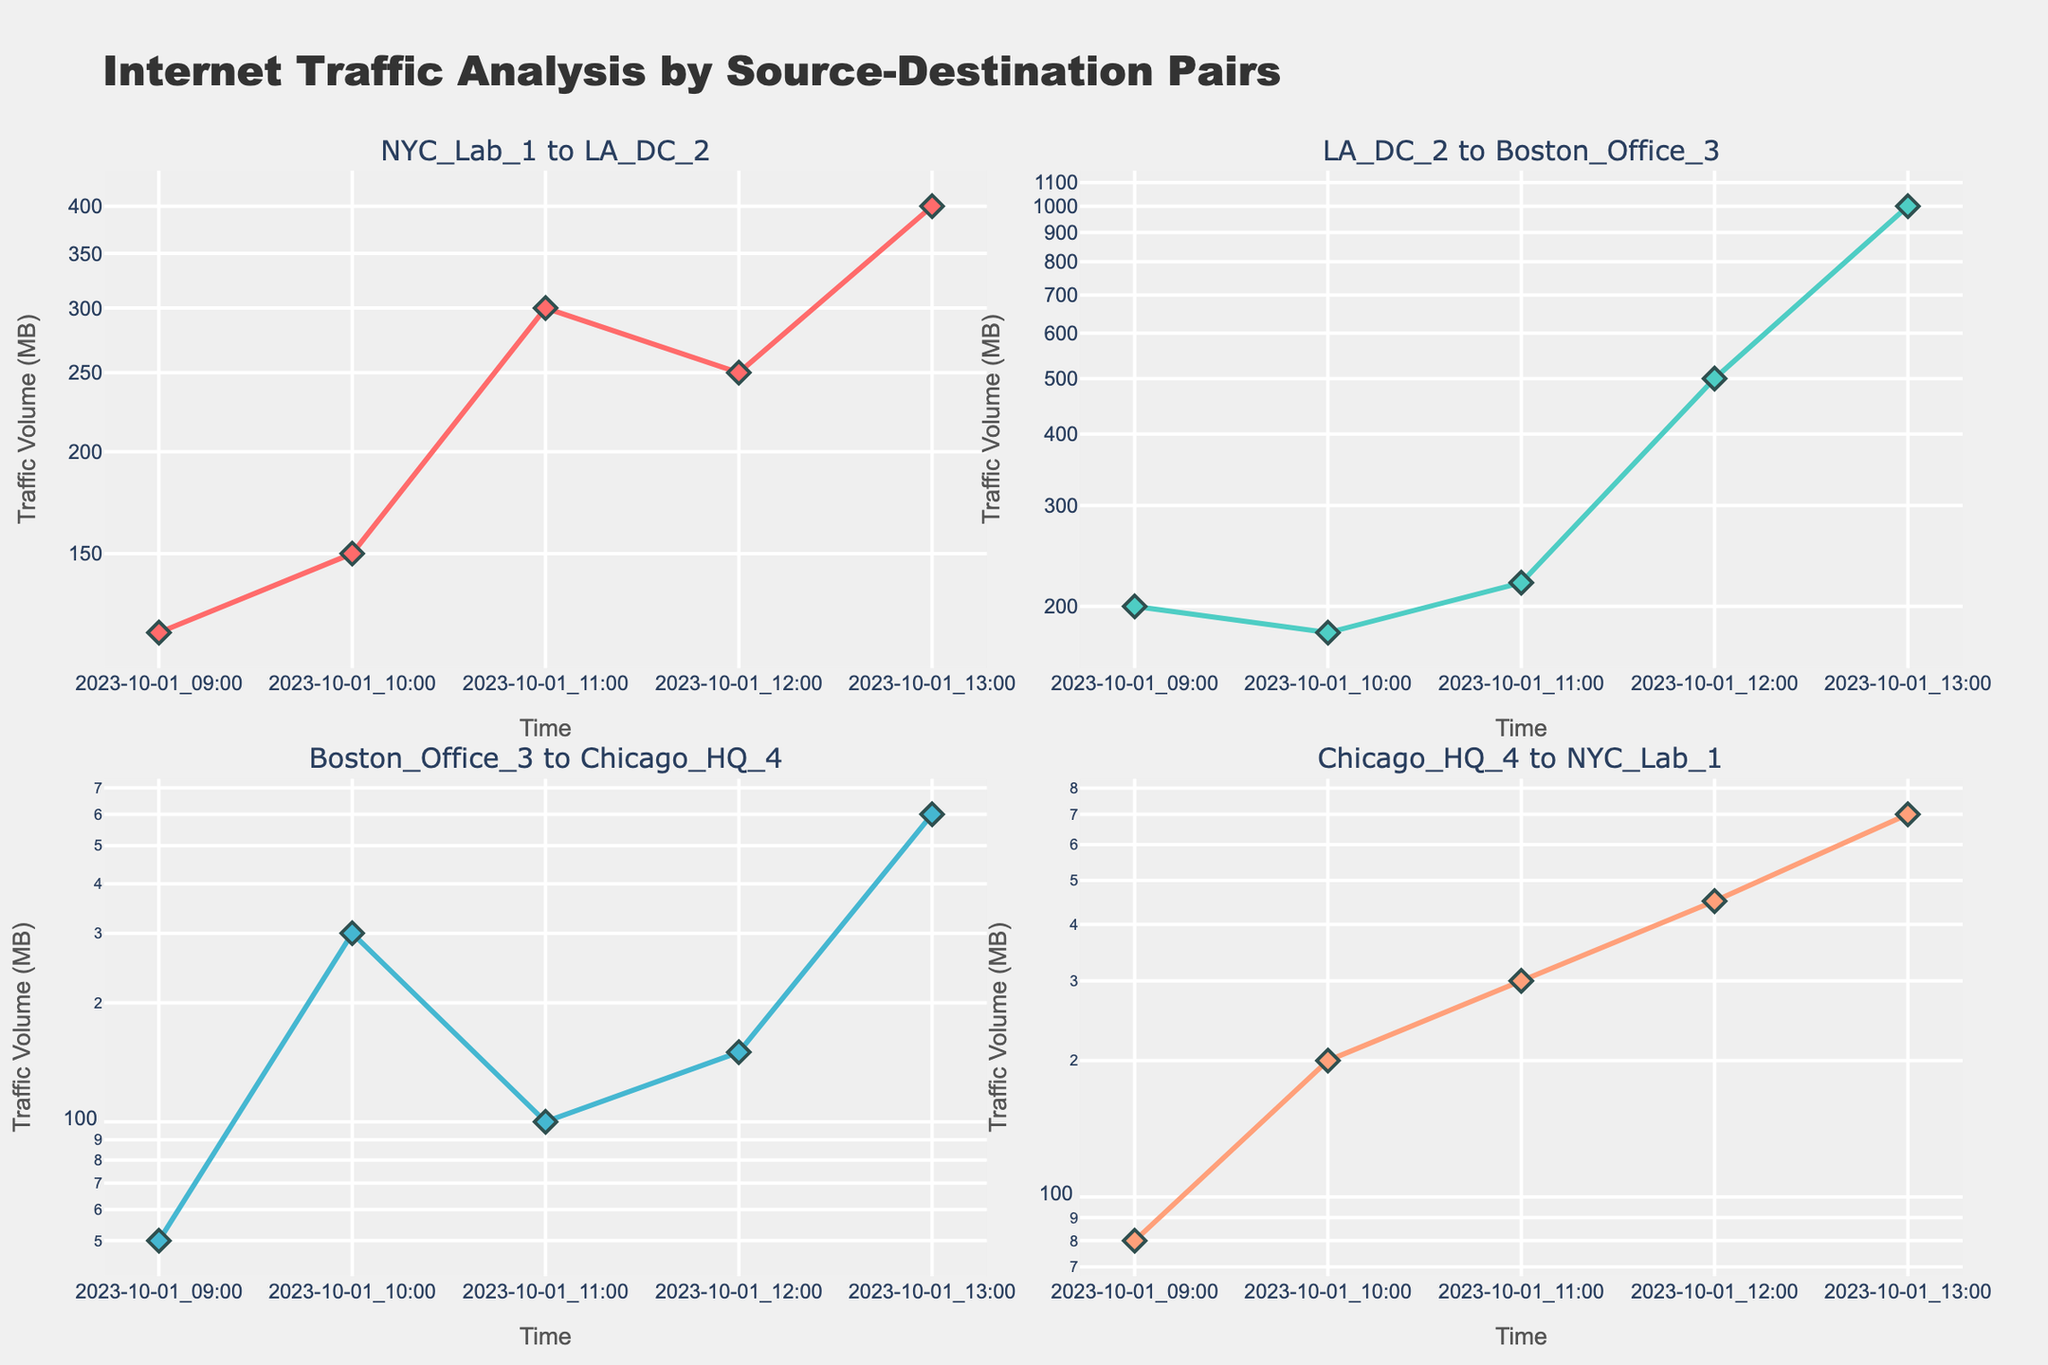What is the title of the figure? The title is displayed at the top of the figure in a larger font size, often descriptive of the overall content or analysis shown in the subplots. The title here is "Internet Traffic Analysis by Source-Destination Pairs".
Answer: Internet Traffic Analysis by Source-Destination Pairs What is the y-axis title in each subplot? Each subplot has a y-axis title that indicates the unit of measurement, which is "Traffic Volume (MB)" as shown next to each y-axis.
Answer: Traffic Volume (MB) How many data points are displayed for the NYC_Lab_1 to LA_DC_2 connection? Counting the markers (diamonds) in the subplot corresponding to NYC_Lab_1 to LA_DC_2 reveals how many data points are presented. This subplot displays 5 data points.
Answer: 5 Which connection shows the highest traffic volume at 13:00? By comparing the y-values at the 13:00 timestamp across all subplots, the highest traffic volume is shown in the LA_DC_2 to Boston_Office_3 connection, which reaches 1000 MB.
Answer: LA_DC_2 to Boston_Office_3 What is the trend in traffic volume for the Boston_Office_3 to Chicago_HQ_4 connection? Observing the line in the subplot for Boston_Office_3 to Chicago_HQ_4, the trend starts with a low volume, spikes at 10:00, decreases again, and then sees another jump at 13:00. This indicates an overall fluctuating pattern with two significant peaks.
Answer: Fluctuating with peaks at 10:00 and 13:00 Compare the traffic volume at 12:00 between the LA_DC_2 to Boston_Office_3 and Chicago_HQ_4 to NYC_Lab_1 connections. Which is higher? Checking the y-values at the 12:00 mark for both connections, LA_DC_2 to Boston_Office_3 has 500 MB while Chicago_HQ_4 to NYC_Lab_1 has 450 MB. Hence, LA_DC_2 to Boston_Office_3 is higher.
Answer: LA_DC_2 to Boston_Office_3 What is the rate of change in traffic volume for the NYC_Lab_1 to LA_DC_2 connection between 11:00 and 12:00? Calculate the difference in traffic volume between 11:00 (300 MB) and 12:00 (250 MB). The change is 250 - 300 = -50 MB, indicating a decrease.
Answer: -50 MB Identify the connection with the smallest traffic volume overall. By examining the minimum traffic volume in each subplot, the Boston_Office_3 to Chicago_HQ_4 connection shows the smallest value of 50 MB.
Answer: Boston_Office_3 to Chicago_HQ_4 Compare the total traffic volume from 09:00 to 13:00 for the NYC_Lab_1 to LA_DC_2 and LA_DC_2 to Boston_Office_3 connections. Which one has a higher total volume? Summing the traffic volumes for NYC_Lab_1 to LA_DC_2 (120 + 150 + 300 + 250 + 400 = 1220 MB) and LA_DC_2 to Boston_Office_3 (200 + 180 + 220 + 500 + 1000 = 2100 MB), LA_DC_2 to Boston_Office_3 has a higher total volume.
Answer: LA_DC_2 to Boston_Office_3 Which subplot has the most rapid exponential growth? By observing the rate of increase in the y-values on a log scale, the LA_DC_2 to Boston_Office_3 subplot shows the most rapid exponential growth, noticeably reflected in the sharp spike from 11:00 to 13:00.
Answer: LA_DC_2 to Boston_Office_3 